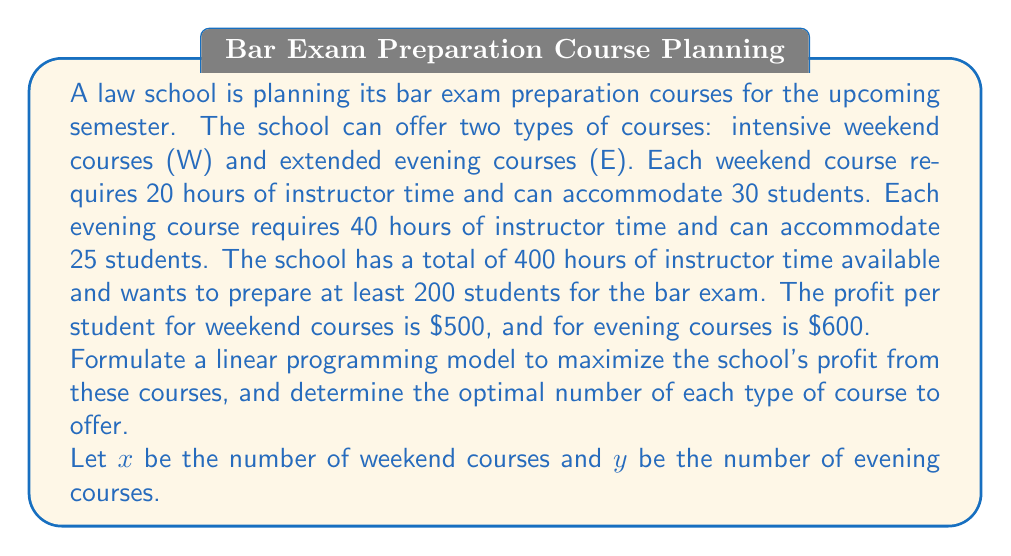What is the answer to this math problem? To solve this optimization problem, we'll follow these steps:

1. Define the objective function
2. Identify the constraints
3. Set up the linear programming model
4. Solve the model using the graphical method

Step 1: Define the objective function

The objective is to maximize profit. The profit per course is:
- Weekend course: $500 * 30 = $15,000
- Evening course: $600 * 25 = $15,000

Objective function: Maximize $Z = 15000x + 15000y$

Step 2: Identify the constraints

a) Instructor time constraint:
   $20x + 40y \leq 400$

b) Minimum number of students constraint:
   $30x + 25y \geq 200$

c) Non-negativity constraints:
   $x \geq 0$, $y \geq 0$

Step 3: Set up the linear programming model

Maximize $Z = 15000x + 15000y$
Subject to:
$20x + 40y \leq 400$
$30x + 25y \geq 200$
$x \geq 0$, $y \geq 0$

Step 4: Solve the model using the graphical method

a) Plot the constraints:
   $20x + 40y = 400$ ⇒ $y = 10 - 0.5x$
   $30x + 25y = 200$ ⇒ $y = 8 - 1.2x$

b) Identify the feasible region (the area that satisfies all constraints)

c) Find the corner points of the feasible region:
   (0, 8), (6.67, 6.67), (10, 5), (0, 10)

d) Evaluate the objective function at each corner point:
   (0, 8):   $Z = 15000(0) + 15000(8) = 120,000$
   (6.67, 6.67): $Z = 15000(6.67) + 15000(6.67) = 200,100$
   (10, 5):  $Z = 15000(10) + 15000(5) = 225,000$
   (0, 10):  $Z = 15000(0) + 15000(10) = 150,000$

The maximum value occurs at the point (10, 5).
Answer: The optimal solution is to offer 10 weekend courses and 5 evening courses, which will result in a maximum profit of $225,000. 